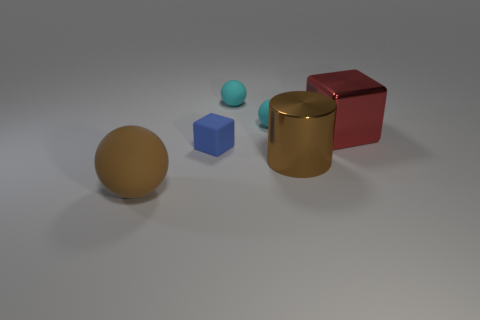Can you tell me about the colors and materials of the objects in the image? Certainly! In the image, there are five objects with varying colors and materials. From left to right, we have a matte brown sphere, a small shiny teal ball, a tiny matte blue cube, a shiny gold cylinder, and a matte red cube. 